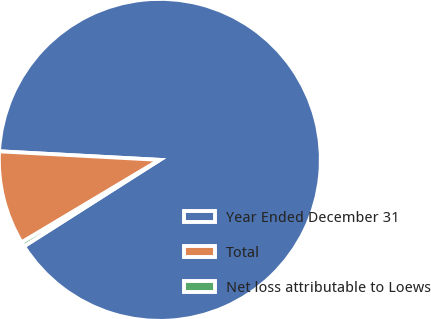<chart> <loc_0><loc_0><loc_500><loc_500><pie_chart><fcel>Year Ended December 31<fcel>Total<fcel>Net loss attributable to Loews<nl><fcel>90.14%<fcel>9.42%<fcel>0.45%<nl></chart> 